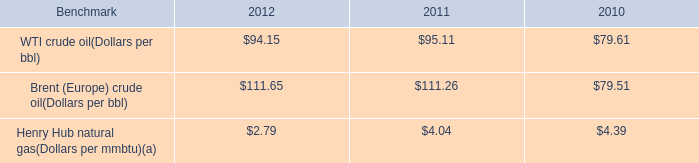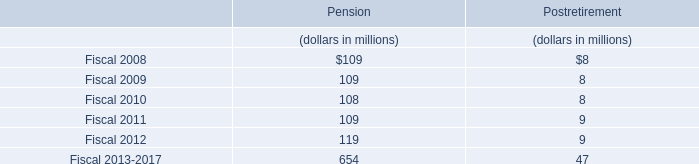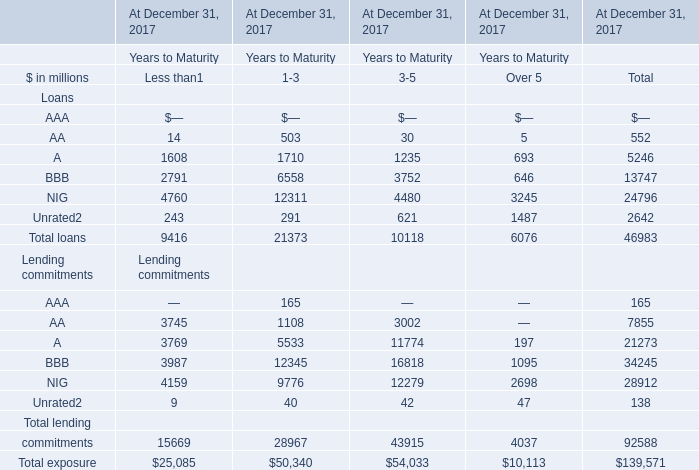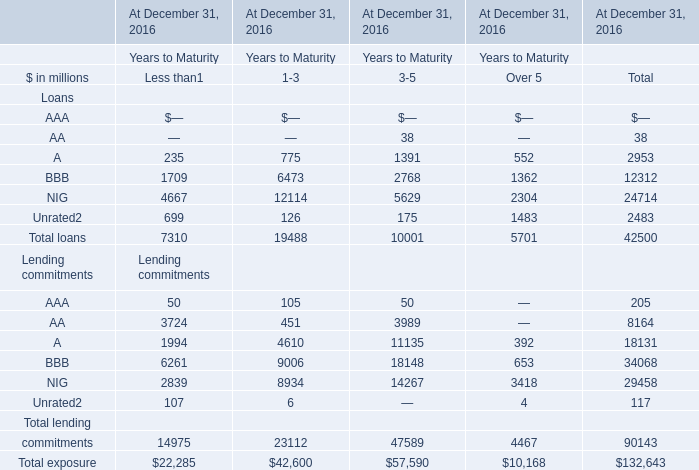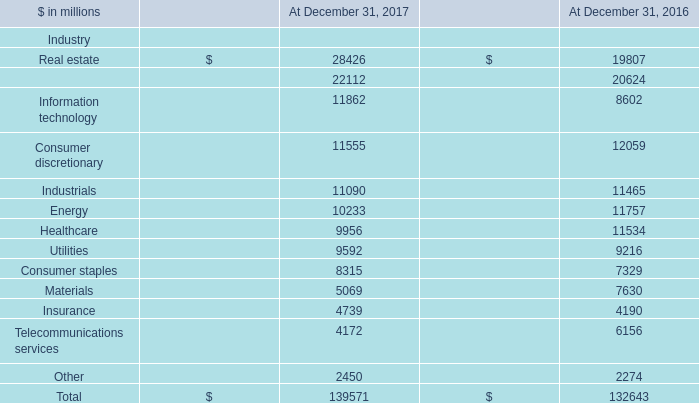what's the total amount of AA Loans of At December 31, 2017 Years to Maturity.1, Utilities of At December 31, 2017, and Insurance of At December 31, 2017 ? 
Computations: ((1108.0 + 9592.0) + 4739.0)
Answer: 15439.0. 